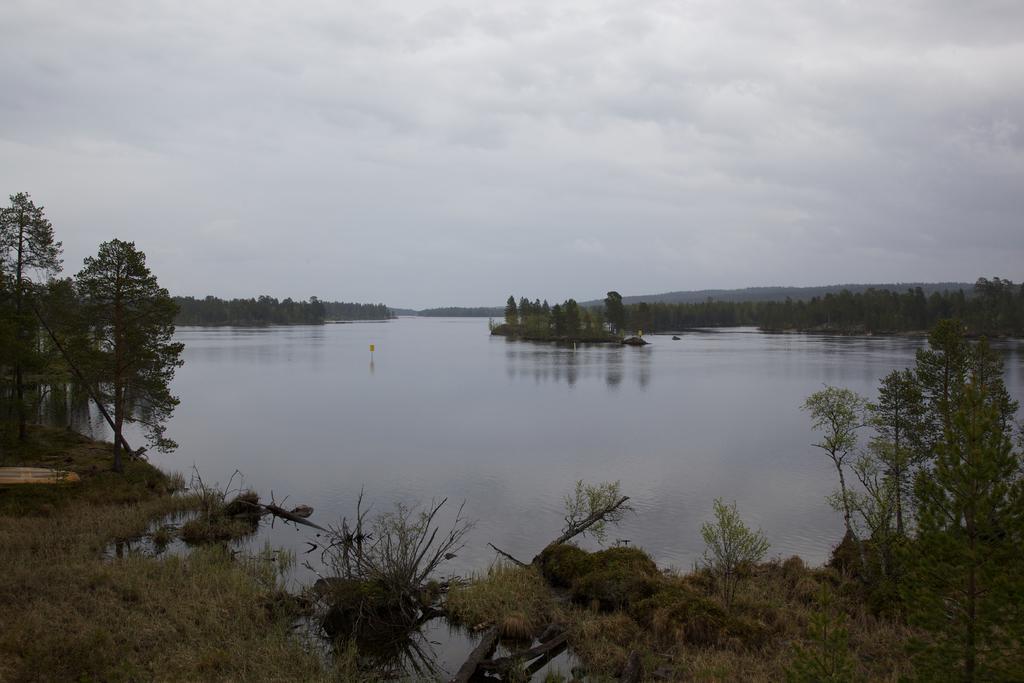Can you describe this image briefly? In this image, we can see plants, grass, water, trees, pole and object. Background we can see the cloudy sky. 